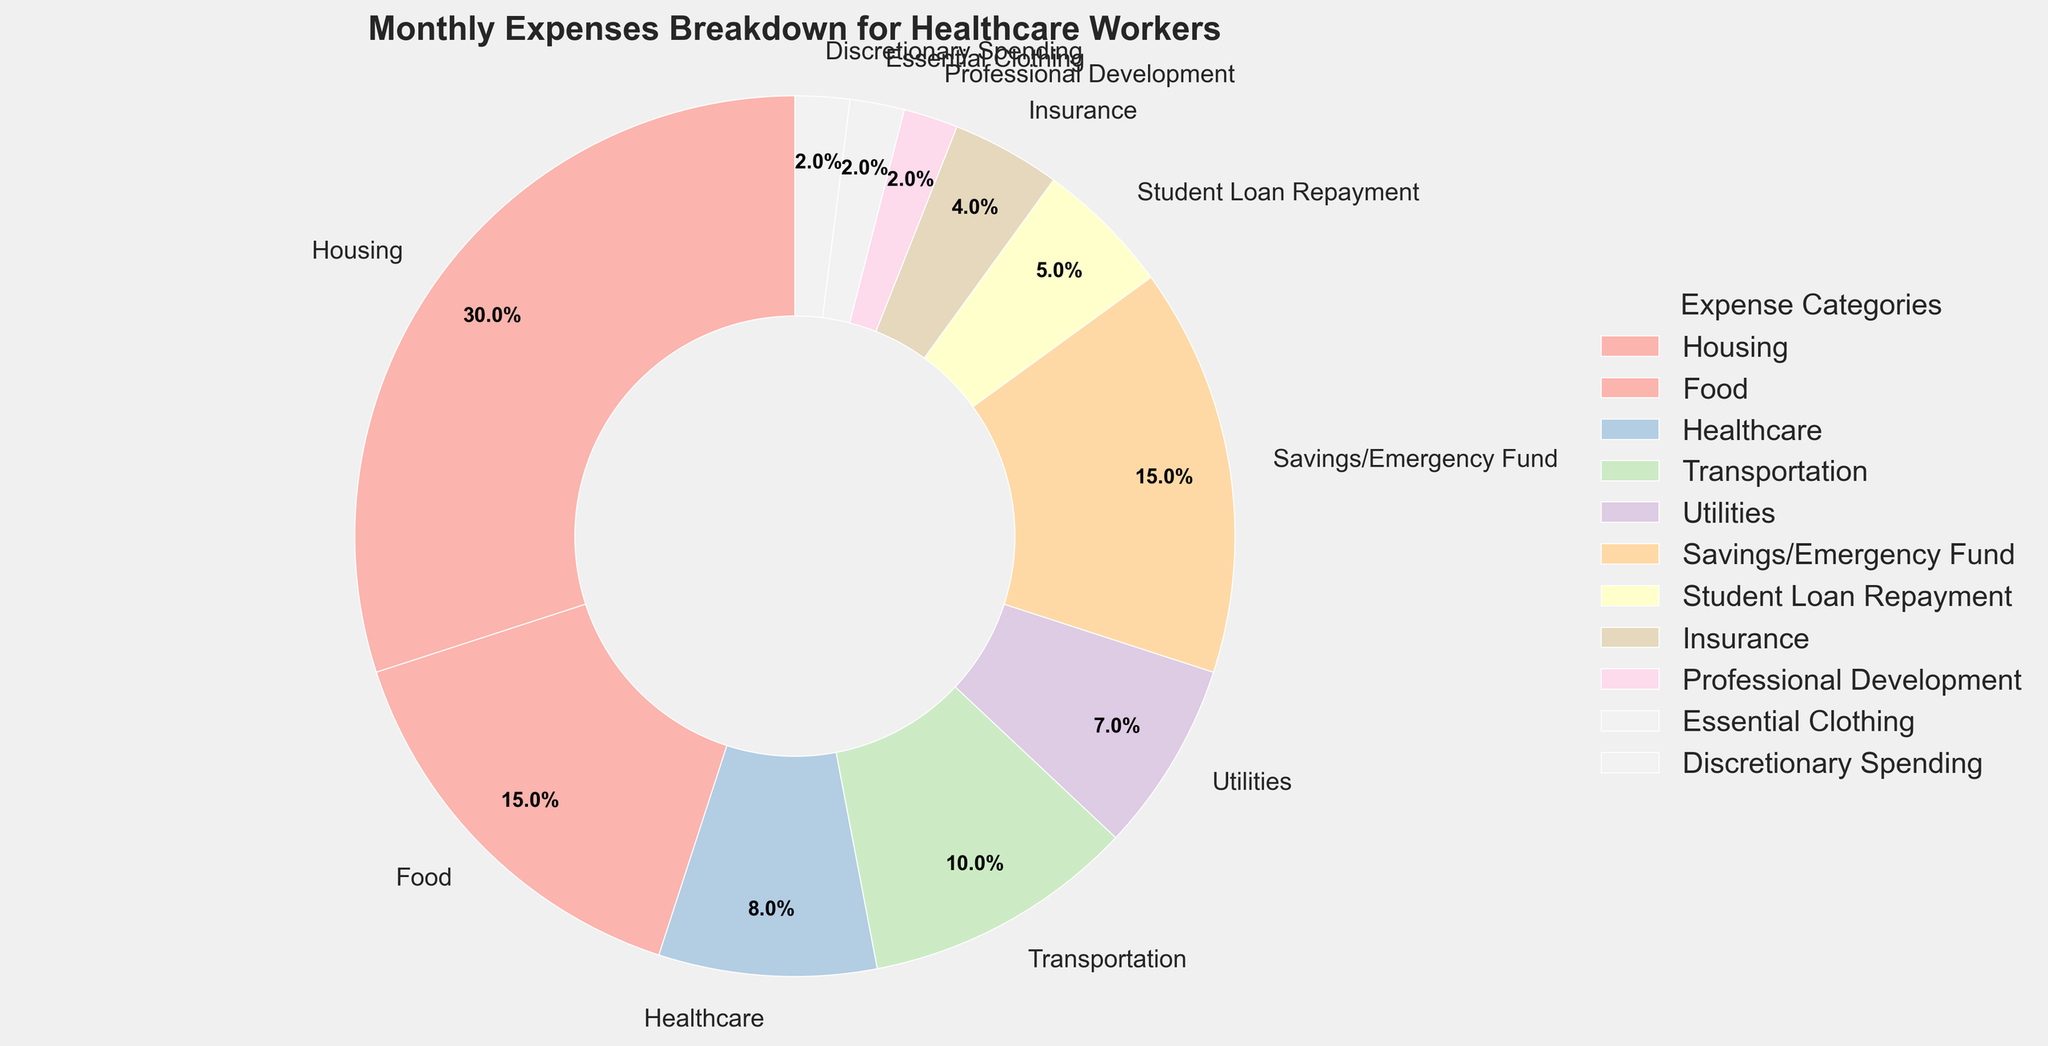What is the largest category in the pie chart? The largest slice in the pie chart is labeled "Housing," which occupies 30% of the total monthly expenses.
Answer: Housing Which category has a smaller percentage: Healthcare or Insurance? By comparing the slices for Healthcare and Insurance, we see that Healthcare has 8% while Insurance has 4%, so Insurance has a smaller percentage.
Answer: Insurance What is the combined percentage of Food and Transportation expenses? Adding the percentages of the Food (15%) and Transportation (10%) slices gives us 15% + 10% = 25%.
Answer: 25% Are Savings/Emergency Fund expenses greater than Housing expenses? By comparing the two slices, we see that Savings/Emergency Fund is 15% and Housing is 30%, so Housing expenses are greater.
Answer: No What percentage of the total expenses is allocated to essential spending categories (Housing, Food, Healthcare, Transportation, Utilities, Essential Clothing, Savings/Emergency Fund)? Adding the percentages of Housing (30%), Food (15%), Healthcare (8%), Transportation (10%), Utilities (7%), Essential Clothing (2%), and Savings/Emergency Fund (15%) gives us 30% + 15% + 8% + 10% + 7% + 2% + 15% = 87%.
Answer: 87% What is the visual appearance (color) of the Professional Development category in the pie chart? The slice representing Professional Development is typically in a distinct pastel color to differentiate it visually, but for exact color interpretation, we assume it's in one of the lighter pastel shades as per the chart.
Answer: Light pastel shade How does the percentage of Student Loan Repayment compare to Discretionary Spending? Both categories have slices in the pie chart, with Student Loan Repayment at 5% and Discretionary Spending at 2%, so Student Loan Repayment percentage is higher.
Answer: Student Loan Repayment If you sum up the percentages of all categories except for Housing and Food, what do you get? Summing the percentages of Healthcare (8%), Transportation (10%), Utilities (7%), Savings/Emergency Fund (15%), Student Loan Repayment (5%), Insurance (4%), Professional Development (2%), Essential Clothing (2%), and Discretionary Spending (2%) gives us 8% + 10% + 7% + 15% + 5% + 4% + 2% + 2% + 2% = 55%.
Answer: 55% Is the percentage spent on Healthcare greater than that spent on Transportation and Utilities combined? Adding the percentages for Transportation (10%) and Utilities (7%) gives us 10% + 7% = 17%, which is greater than the 8% spent on Healthcare.
Answer: No 